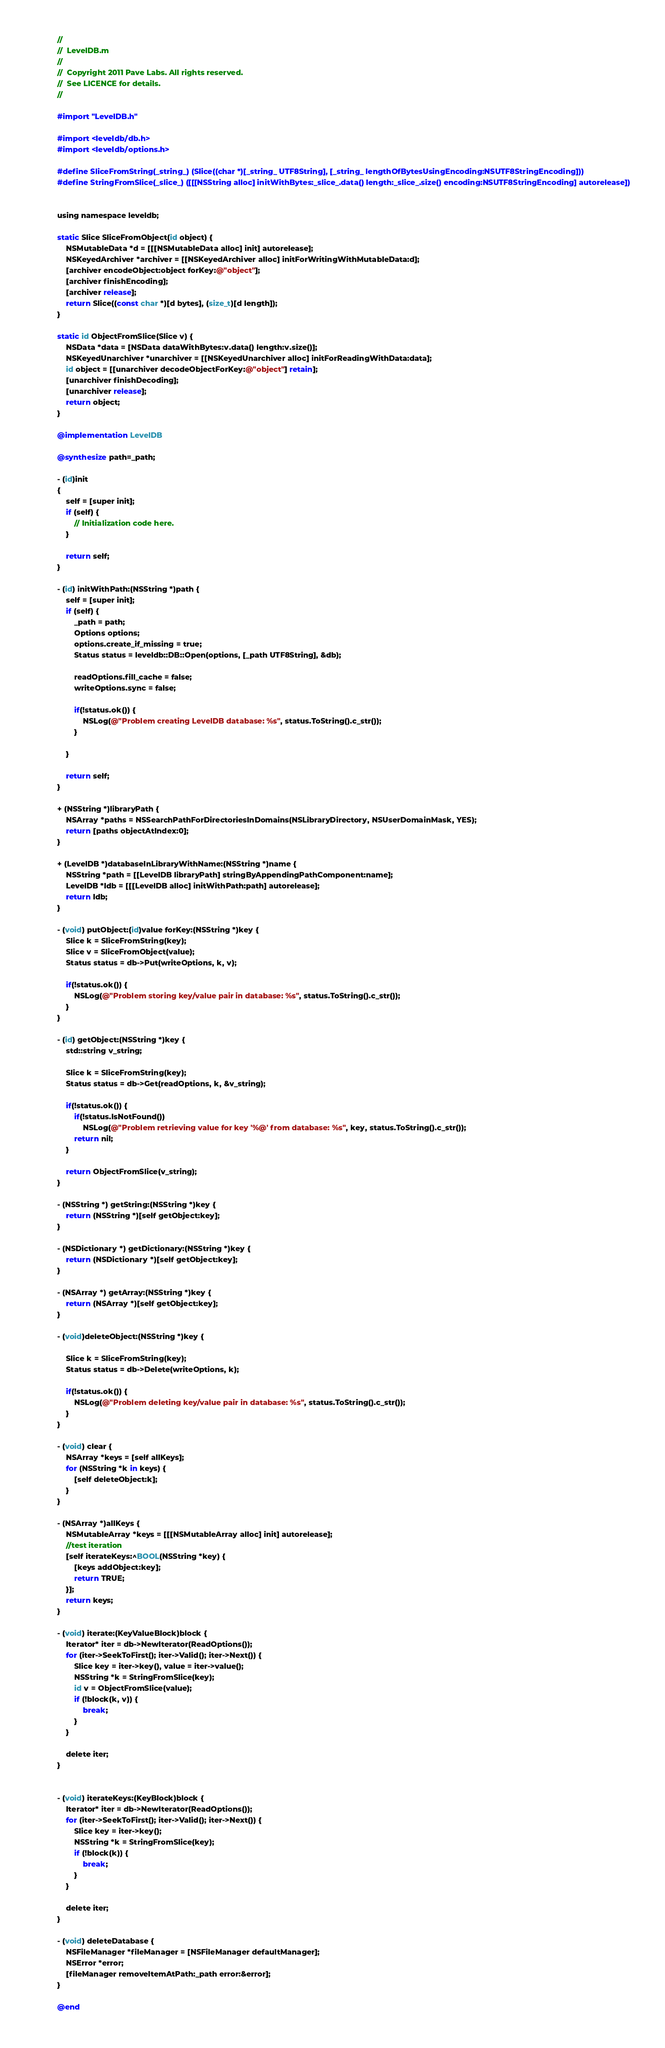<code> <loc_0><loc_0><loc_500><loc_500><_ObjectiveC_>//
//  LevelDB.m
//
//  Copyright 2011 Pave Labs. All rights reserved. 
//  See LICENCE for details.
//

#import "LevelDB.h"

#import <leveldb/db.h>
#import <leveldb/options.h>

#define SliceFromString(_string_) (Slice((char *)[_string_ UTF8String], [_string_ lengthOfBytesUsingEncoding:NSUTF8StringEncoding]))
#define StringFromSlice(_slice_) ([[[NSString alloc] initWithBytes:_slice_.data() length:_slice_.size() encoding:NSUTF8StringEncoding] autorelease])


using namespace leveldb;

static Slice SliceFromObject(id object) {
    NSMutableData *d = [[[NSMutableData alloc] init] autorelease];
    NSKeyedArchiver *archiver = [[NSKeyedArchiver alloc] initForWritingWithMutableData:d];
    [archiver encodeObject:object forKey:@"object"];
    [archiver finishEncoding];
    [archiver release];
    return Slice((const char *)[d bytes], (size_t)[d length]);
}

static id ObjectFromSlice(Slice v) {
    NSData *data = [NSData dataWithBytes:v.data() length:v.size()];
    NSKeyedUnarchiver *unarchiver = [[NSKeyedUnarchiver alloc] initForReadingWithData:data];
    id object = [[unarchiver decodeObjectForKey:@"object"] retain];
    [unarchiver finishDecoding];
    [unarchiver release];
    return object;
}

@implementation LevelDB 

@synthesize path=_path;

- (id)init
{
    self = [super init];
    if (self) {
        // Initialization code here.
    }
    
    return self;
}

- (id) initWithPath:(NSString *)path {
    self = [super init];
    if (self) {
        _path = path;
        Options options;
        options.create_if_missing = true;
        Status status = leveldb::DB::Open(options, [_path UTF8String], &db);
        
        readOptions.fill_cache = false;
        writeOptions.sync = false;
        
        if(!status.ok()) {
            NSLog(@"Problem creating LevelDB database: %s", status.ToString().c_str());
        }
        
    }
    
    return self;
}

+ (NSString *)libraryPath {
    NSArray *paths = NSSearchPathForDirectoriesInDomains(NSLibraryDirectory, NSUserDomainMask, YES);
    return [paths objectAtIndex:0];
}

+ (LevelDB *)databaseInLibraryWithName:(NSString *)name {
    NSString *path = [[LevelDB libraryPath] stringByAppendingPathComponent:name];
    LevelDB *ldb = [[[LevelDB alloc] initWithPath:path] autorelease];
    return ldb;
}

- (void) putObject:(id)value forKey:(NSString *)key {
    Slice k = SliceFromString(key);
    Slice v = SliceFromObject(value);
    Status status = db->Put(writeOptions, k, v);
    
    if(!status.ok()) {
        NSLog(@"Problem storing key/value pair in database: %s", status.ToString().c_str());
    }
}

- (id) getObject:(NSString *)key {
    std::string v_string;
    
    Slice k = SliceFromString(key);
    Status status = db->Get(readOptions, k, &v_string);
    
    if(!status.ok()) {
        if(!status.IsNotFound())
            NSLog(@"Problem retrieving value for key '%@' from database: %s", key, status.ToString().c_str());
        return nil;
    }
    
    return ObjectFromSlice(v_string);
}

- (NSString *) getString:(NSString *)key {
    return (NSString *)[self getObject:key];
}

- (NSDictionary *) getDictionary:(NSString *)key {
    return (NSDictionary *)[self getObject:key];
}

- (NSArray *) getArray:(NSString *)key {
    return (NSArray *)[self getObject:key];
}

- (void)deleteObject:(NSString *)key {
    
    Slice k = SliceFromString(key);
    Status status = db->Delete(writeOptions, k);
    
    if(!status.ok()) {
        NSLog(@"Problem deleting key/value pair in database: %s", status.ToString().c_str());
    }
}

- (void) clear {
    NSArray *keys = [self allKeys];
    for (NSString *k in keys) {
        [self deleteObject:k];
    }
}

- (NSArray *)allKeys {
    NSMutableArray *keys = [[[NSMutableArray alloc] init] autorelease];
    //test iteration
    [self iterateKeys:^BOOL(NSString *key) {
        [keys addObject:key];
        return TRUE;
    }];
    return keys;
}

- (void) iterate:(KeyValueBlock)block {
    Iterator* iter = db->NewIterator(ReadOptions());
    for (iter->SeekToFirst(); iter->Valid(); iter->Next()) {
        Slice key = iter->key(), value = iter->value();
        NSString *k = StringFromSlice(key);
        id v = ObjectFromSlice(value);
        if (!block(k, v)) {
            break;
        }
    }

    delete iter;
}


- (void) iterateKeys:(KeyBlock)block {
    Iterator* iter = db->NewIterator(ReadOptions());
    for (iter->SeekToFirst(); iter->Valid(); iter->Next()) {
        Slice key = iter->key();
        NSString *k = StringFromSlice(key);
        if (!block(k)) {
            break;
        }
    }

    delete iter;
}

- (void) deleteDatabase {
    NSFileManager *fileManager = [NSFileManager defaultManager];
    NSError *error;
    [fileManager removeItemAtPath:_path error:&error];
}

@end
</code> 